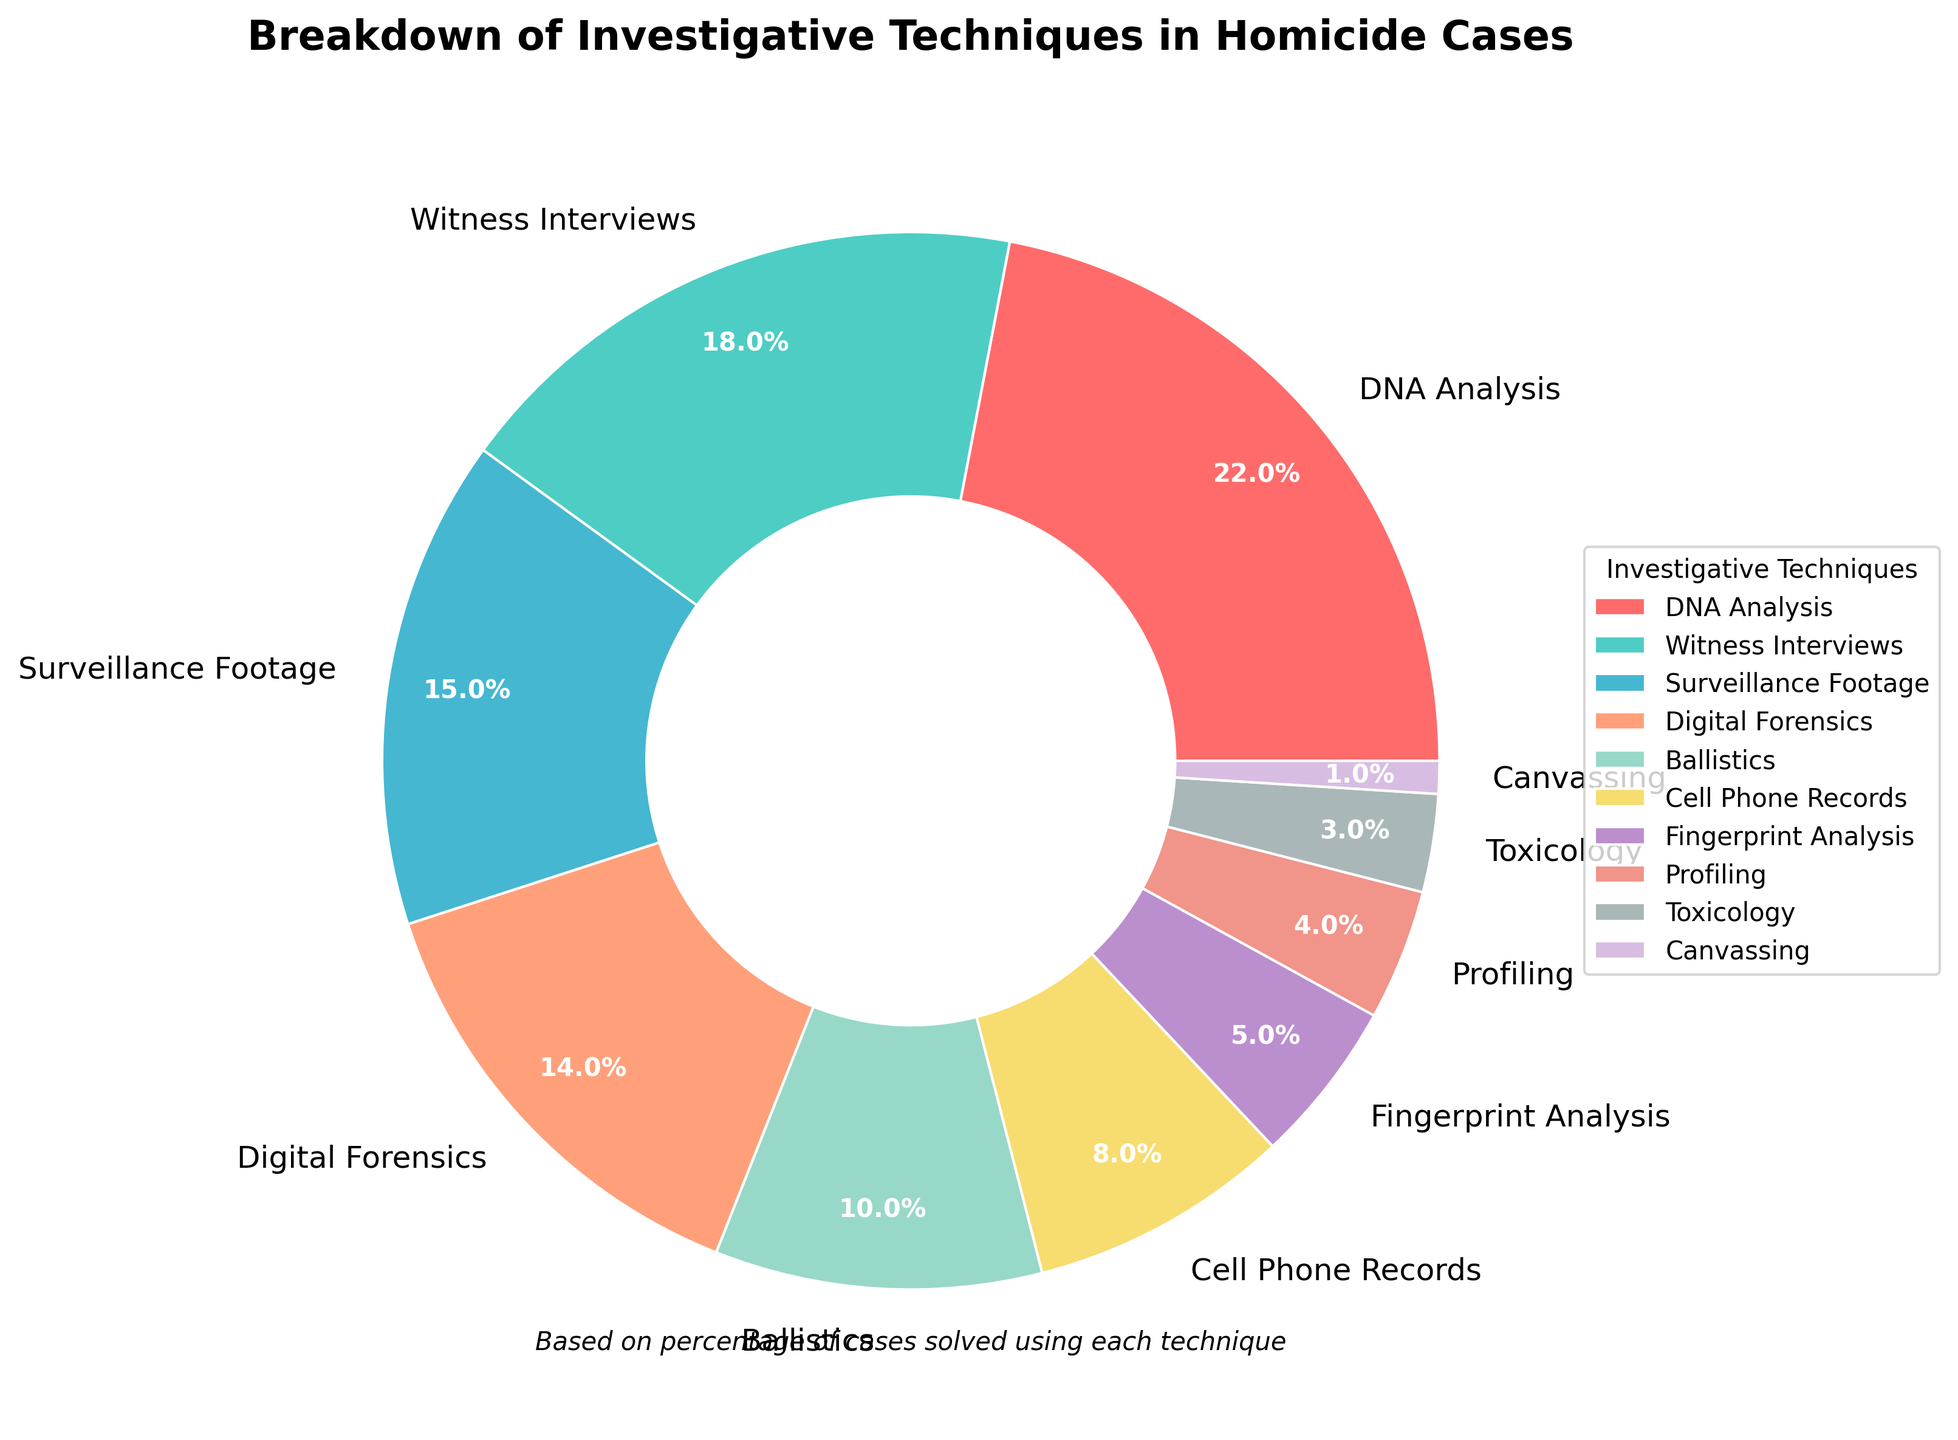what percentage of cases were solved using DNA Analysis and Digital Forensics combined? Sum the percentages of DNA Analysis and Digital Forensics (22% + 14% = 36%).
Answer: 36% Which investigative technique was used the least frequently? Identify the category with the smallest percentage value, which is Canvassing with 1%.
Answer: Canvassing Compare the usage of Ballistics and Surveillance Footage. Which one is used more frequently and by how much? Surveillance Footage (15%) is used more frequently than Ballistics (10%), and the difference is calculated as 15% - 10% = 5%.
Answer: Surveillance Footage by 5% What investigative technique is represented by the red color in the pie chart? The visual attributes indicate that the color red (first in the color list) corresponds to DNA Analysis.
Answer: DNA Analysis Out of the total methods, what is the average percentage of usage per technique? Given 10 methods, sum all percentages (22 + 18 + 15 + 14 + 10 + 8 + 5 + 4 + 3 + 1 = 100) and then divide by 10 (100 / 10 = 10).
Answer: 10% Which techniques make up more than 15% each? Identify techniques with percentages greater than 15%; these are DNA Analysis (22%) and Witness Interviews (18%).
Answer: DNA Analysis, Witness Interviews Are there more techniques below or above 10% usage? Categorize the techniques with percentages below 10% (Cell Phone Records, Fingerprint Analysis, Profiling, Toxicology, and Canvassing) and above 10% (DNA Analysis, Witness Interviews, Surveillance Footage, Digital Forensics, Ballistics). There are 5 below and 5 above.
Answer: Equal What is the combined percentage of Fingerprint Analysis, Profiling, and Toxicology? Sum the percentages for Fingerprint Analysis (5%), Profiling (4%), and Toxicology (3%) which is 5% + 4% + 3% = 12%.
Answer: 12% Rank the top three investigative techniques by their usage percentages. List the top three techniques by sorting percentages, which are DNA Analysis (22%), Witness Interviews (18%), and Surveillance Footage (15%).
Answer: DNA Analysis, Witness Interviews, Surveillance Footage 